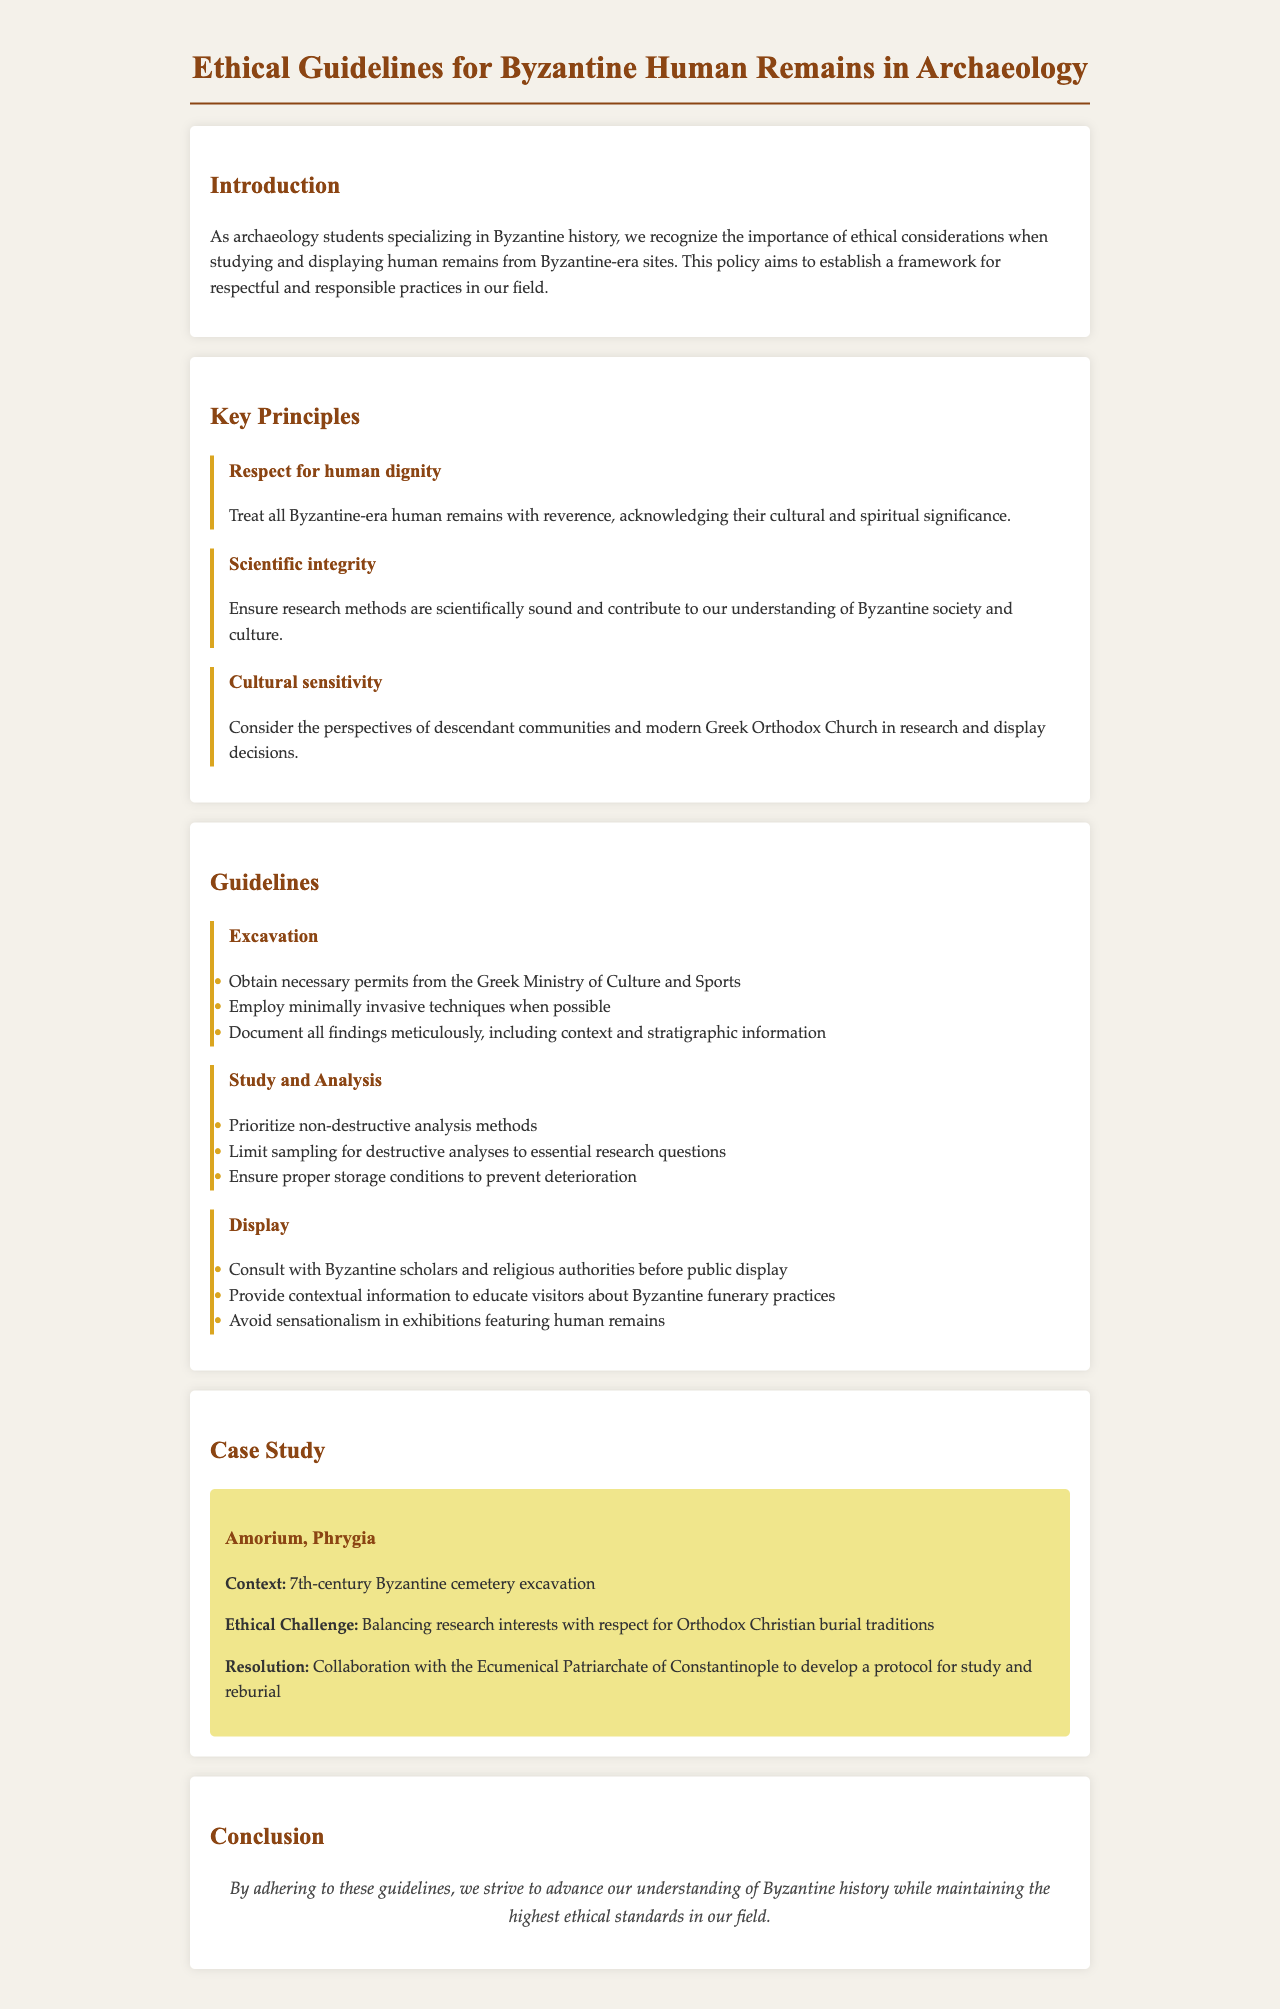What is the primary focus of the document? The document is centered on establishing ethical guidelines for the study and display of human remains from Byzantine-era archaeological sites.
Answer: Ethical guidelines Who should be consulted before public display of human remains? The guidelines recommend consulting with scholars and religious authorities prior to public display.
Answer: Byzantine scholars and religious authorities What century is associated with the case study mentioned? The case study refers to a cemetery excavation from the 7th century.
Answer: 7th-century What is the ethical challenge faced in the Amorium case study? The challenge involves balancing research interests with respect for burial traditions.
Answer: Respect for Orthodox Christian burial traditions What is one key principle included in the document? One of the key principles emphasizes the importance of treating human remains with reverence.
Answer: Respect for human dignity How many guidelines are provided for study and analysis? There are three specific guidelines outlined for study and analysis of human remains.
Answer: Three What type of analysis methods should be prioritized according to the guidelines? Researchers are encouraged to prioritize non-destructive analysis methods in their studies.
Answer: Non-destructive analysis methods What organization is mentioned for collaboration in the Amorium case study? Collaboration was developed with the Ecumenical Patriarchate of Constantinople.
Answer: Ecumenical Patriarchate of Constantinople What does the conclusion of the document emphasize? The conclusion emphasizes the importance of adhering to ethical standards in the field of Byzantine archaeology.
Answer: Highest ethical standards 